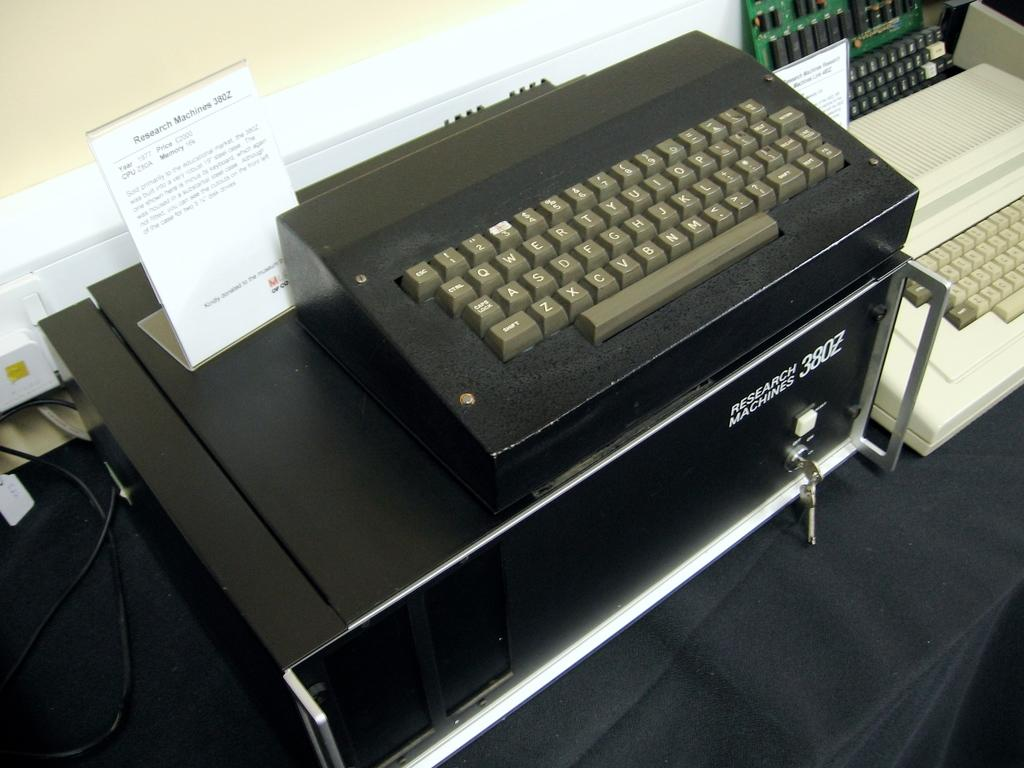<image>
Present a compact description of the photo's key features. Black keyboard on top of a machine that says Research Machines. 